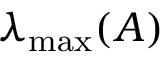Convert formula to latex. <formula><loc_0><loc_0><loc_500><loc_500>\lambda _ { \max } ( A )</formula> 